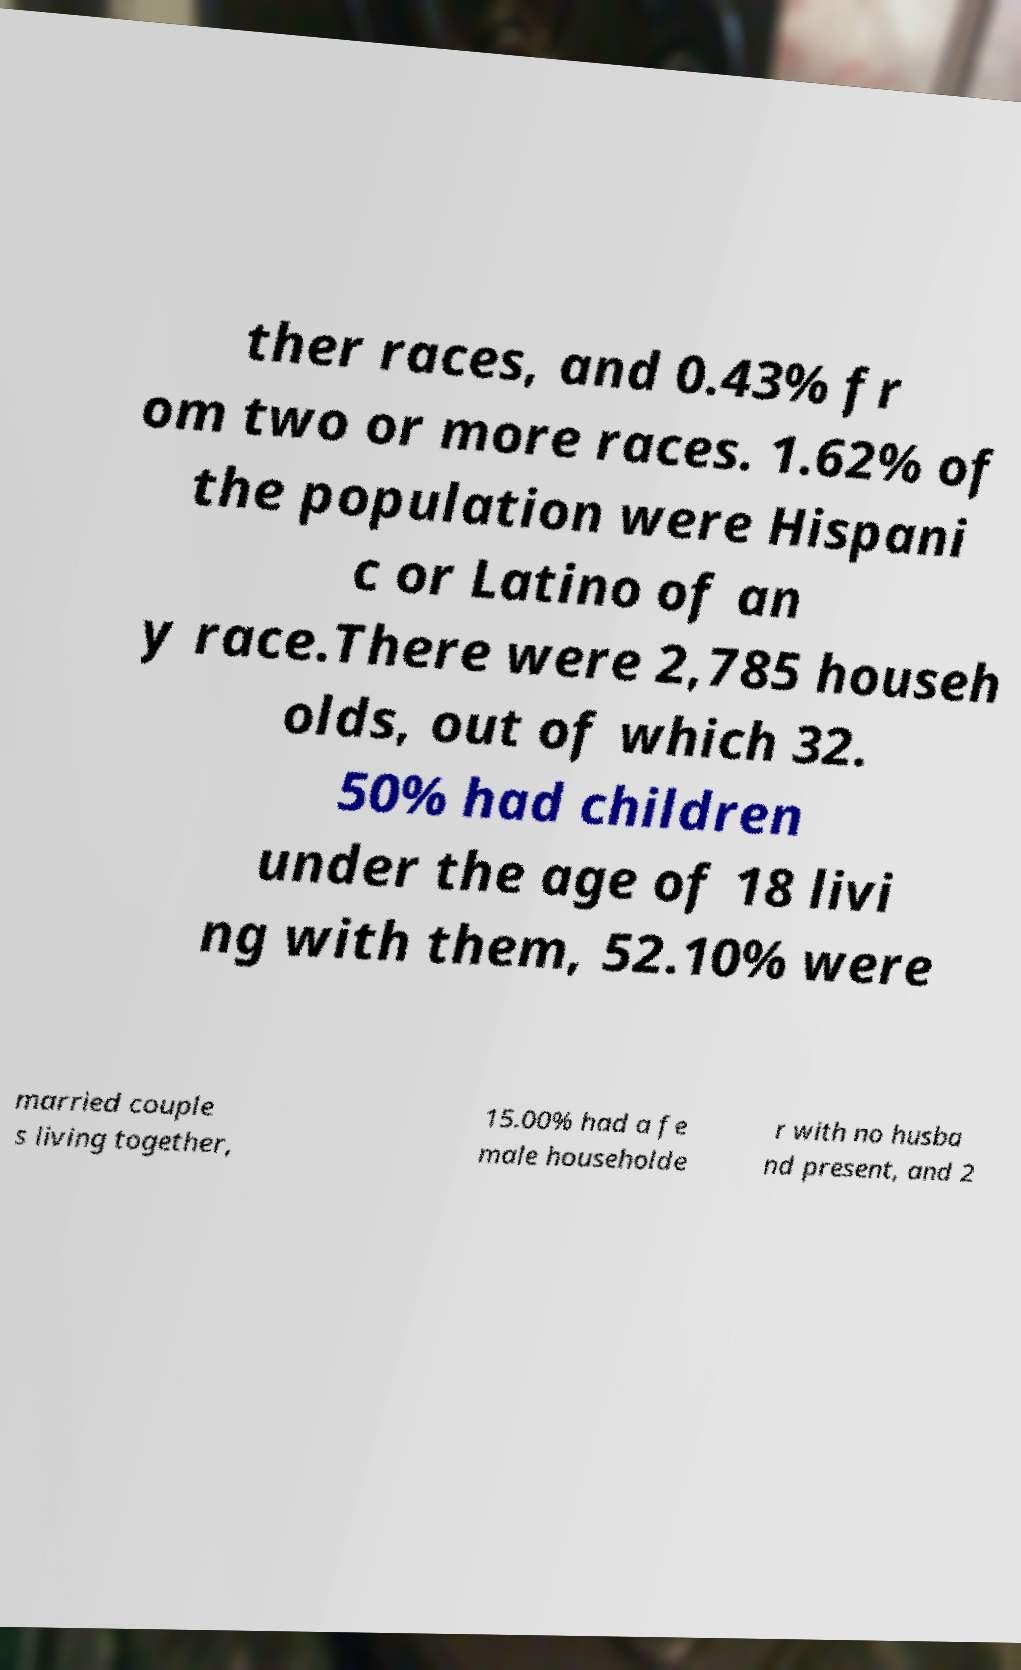Could you extract and type out the text from this image? ther races, and 0.43% fr om two or more races. 1.62% of the population were Hispani c or Latino of an y race.There were 2,785 househ olds, out of which 32. 50% had children under the age of 18 livi ng with them, 52.10% were married couple s living together, 15.00% had a fe male householde r with no husba nd present, and 2 